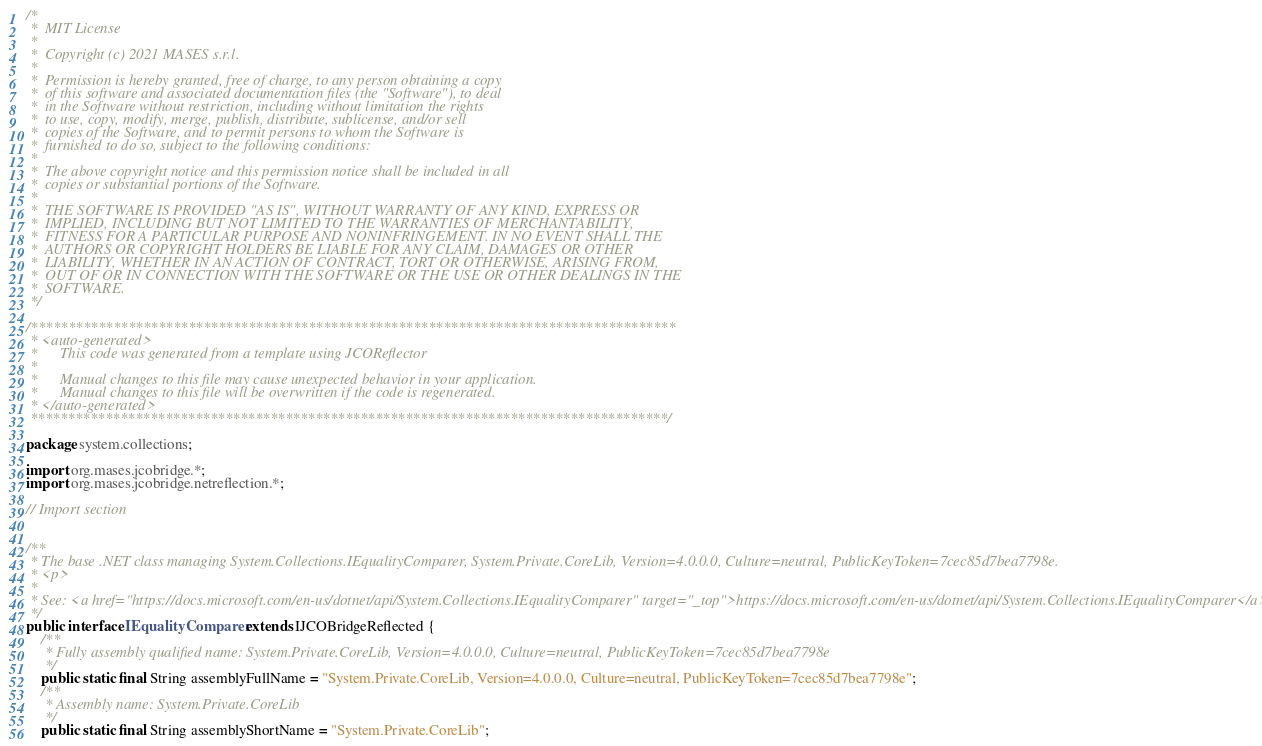Convert code to text. <code><loc_0><loc_0><loc_500><loc_500><_Java_>/*
 *  MIT License
 *
 *  Copyright (c) 2021 MASES s.r.l.
 *
 *  Permission is hereby granted, free of charge, to any person obtaining a copy
 *  of this software and associated documentation files (the "Software"), to deal
 *  in the Software without restriction, including without limitation the rights
 *  to use, copy, modify, merge, publish, distribute, sublicense, and/or sell
 *  copies of the Software, and to permit persons to whom the Software is
 *  furnished to do so, subject to the following conditions:
 *
 *  The above copyright notice and this permission notice shall be included in all
 *  copies or substantial portions of the Software.
 *
 *  THE SOFTWARE IS PROVIDED "AS IS", WITHOUT WARRANTY OF ANY KIND, EXPRESS OR
 *  IMPLIED, INCLUDING BUT NOT LIMITED TO THE WARRANTIES OF MERCHANTABILITY,
 *  FITNESS FOR A PARTICULAR PURPOSE AND NONINFRINGEMENT. IN NO EVENT SHALL THE
 *  AUTHORS OR COPYRIGHT HOLDERS BE LIABLE FOR ANY CLAIM, DAMAGES OR OTHER
 *  LIABILITY, WHETHER IN AN ACTION OF CONTRACT, TORT OR OTHERWISE, ARISING FROM,
 *  OUT OF OR IN CONNECTION WITH THE SOFTWARE OR THE USE OR OTHER DEALINGS IN THE
 *  SOFTWARE.
 */

/**************************************************************************************
 * <auto-generated>
 *      This code was generated from a template using JCOReflector
 * 
 *      Manual changes to this file may cause unexpected behavior in your application.
 *      Manual changes to this file will be overwritten if the code is regenerated.
 * </auto-generated>
 *************************************************************************************/

package system.collections;

import org.mases.jcobridge.*;
import org.mases.jcobridge.netreflection.*;

// Import section


/**
 * The base .NET class managing System.Collections.IEqualityComparer, System.Private.CoreLib, Version=4.0.0.0, Culture=neutral, PublicKeyToken=7cec85d7bea7798e.
 * <p>
 * 
 * See: <a href="https://docs.microsoft.com/en-us/dotnet/api/System.Collections.IEqualityComparer" target="_top">https://docs.microsoft.com/en-us/dotnet/api/System.Collections.IEqualityComparer</a>
 */
public interface IEqualityComparer extends IJCOBridgeReflected {
    /**
     * Fully assembly qualified name: System.Private.CoreLib, Version=4.0.0.0, Culture=neutral, PublicKeyToken=7cec85d7bea7798e
     */
    public static final String assemblyFullName = "System.Private.CoreLib, Version=4.0.0.0, Culture=neutral, PublicKeyToken=7cec85d7bea7798e";
    /**
     * Assembly name: System.Private.CoreLib
     */
    public static final String assemblyShortName = "System.Private.CoreLib";</code> 